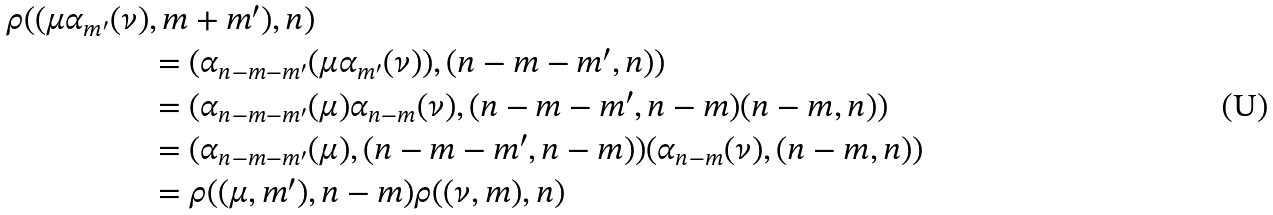<formula> <loc_0><loc_0><loc_500><loc_500>\rho ( ( \mu \alpha _ { m ^ { \prime } } ( \nu ) & , m + m ^ { \prime } ) , n ) \\ & = ( \alpha _ { n - m - m ^ { \prime } } ( \mu \alpha _ { m ^ { \prime } } ( \nu ) ) , ( n - m - m ^ { \prime } , n ) ) \\ & = ( \alpha _ { n - m - m ^ { \prime } } ( \mu ) \alpha _ { n - m } ( \nu ) , ( n - m - m ^ { \prime } , n - m ) ( n - m , n ) ) \\ & = ( \alpha _ { n - m - m ^ { \prime } } ( \mu ) , ( n - m - m ^ { \prime } , n - m ) ) ( \alpha _ { n - m } ( \nu ) , ( n - m , n ) ) \\ & = \rho ( ( \mu , m ^ { \prime } ) , n - m ) \rho ( ( \nu , m ) , n )</formula> 